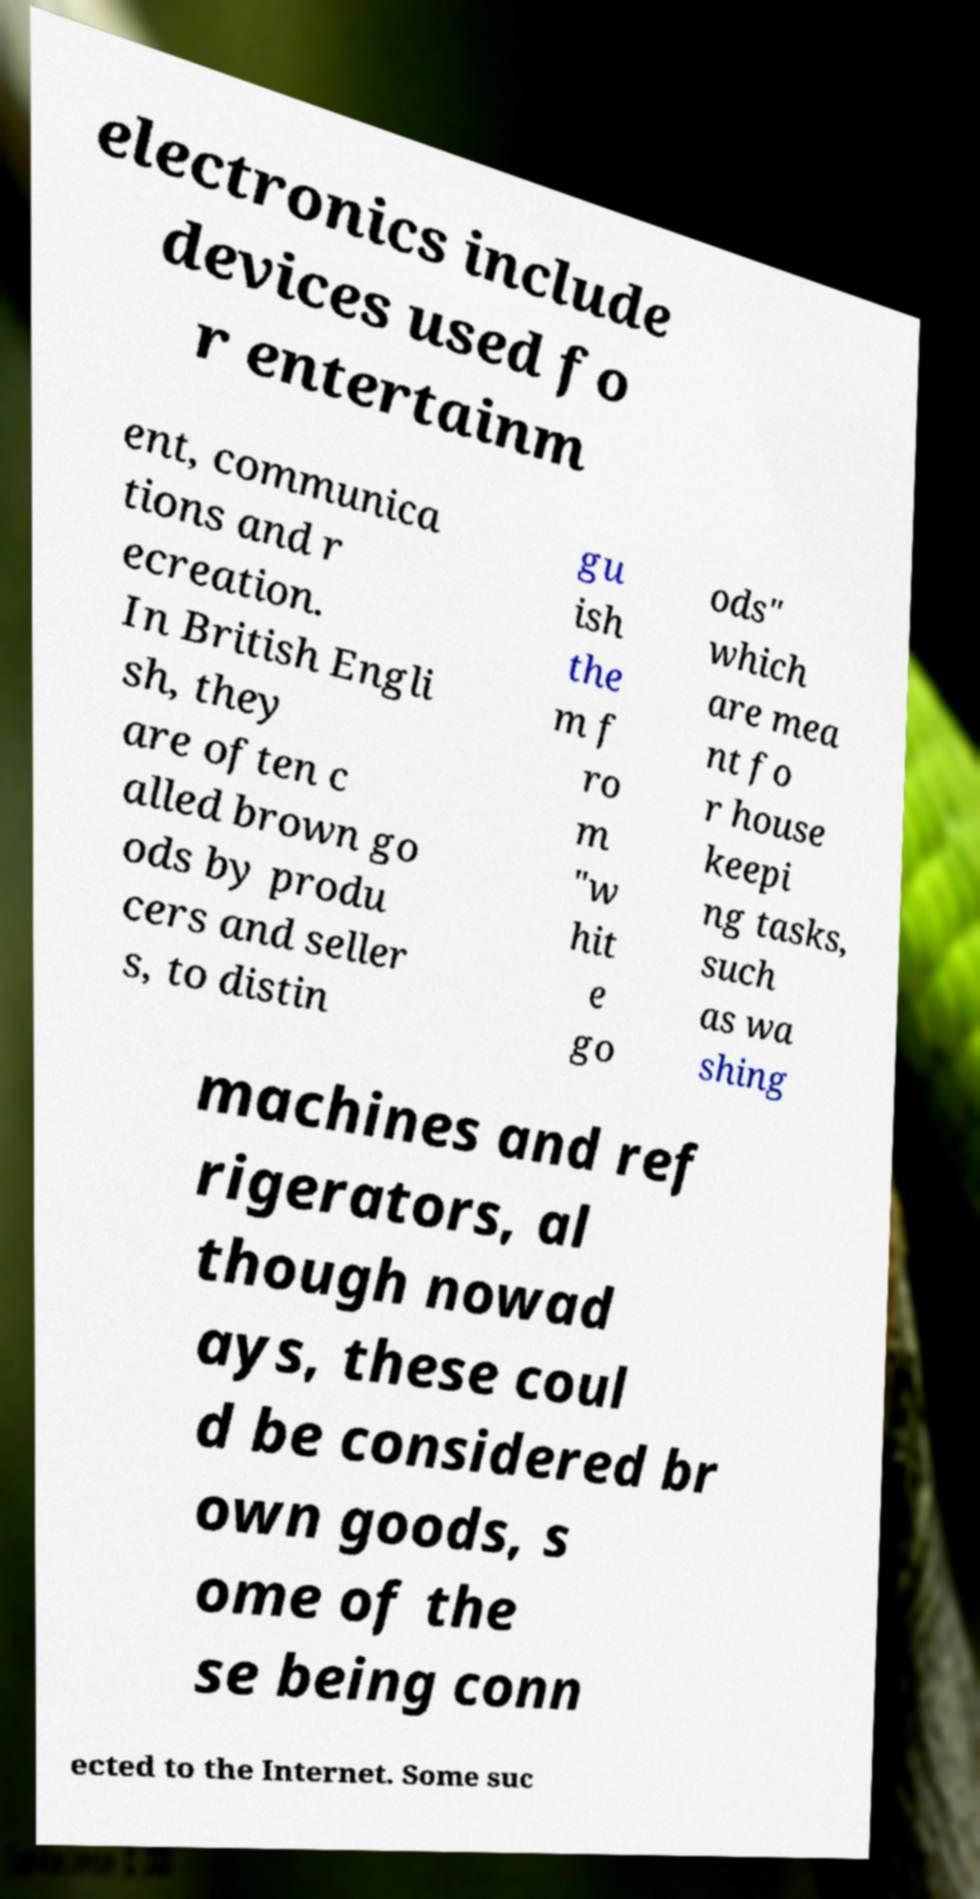Could you extract and type out the text from this image? electronics include devices used fo r entertainm ent, communica tions and r ecreation. In British Engli sh, they are often c alled brown go ods by produ cers and seller s, to distin gu ish the m f ro m "w hit e go ods" which are mea nt fo r house keepi ng tasks, such as wa shing machines and ref rigerators, al though nowad ays, these coul d be considered br own goods, s ome of the se being conn ected to the Internet. Some suc 